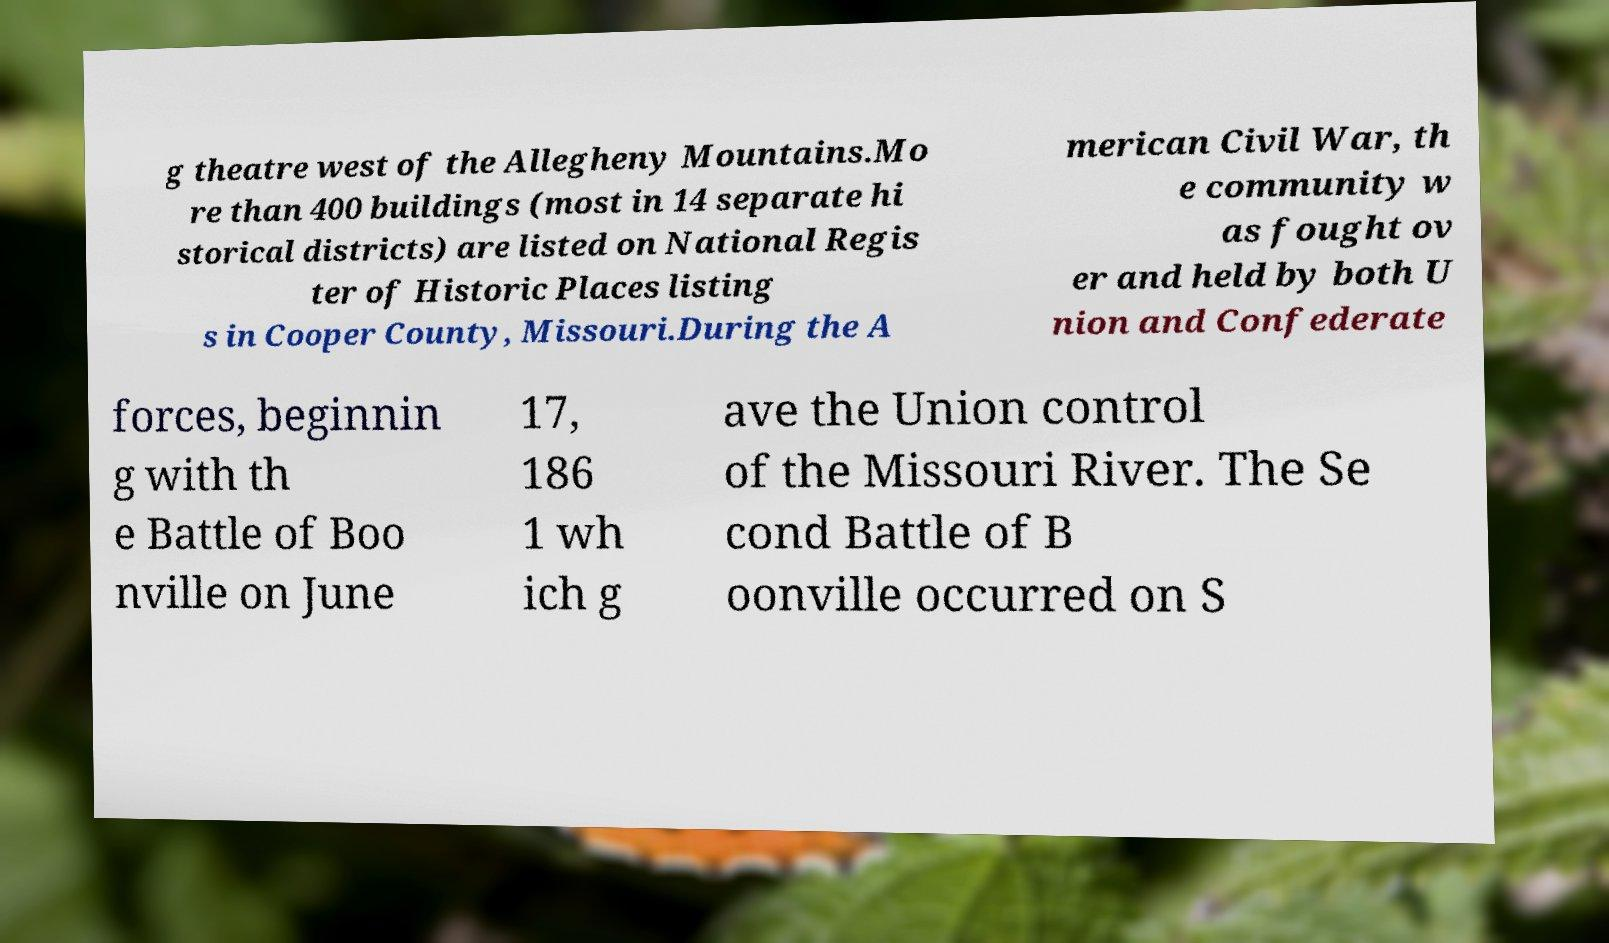Can you accurately transcribe the text from the provided image for me? g theatre west of the Allegheny Mountains.Mo re than 400 buildings (most in 14 separate hi storical districts) are listed on National Regis ter of Historic Places listing s in Cooper County, Missouri.During the A merican Civil War, th e community w as fought ov er and held by both U nion and Confederate forces, beginnin g with th e Battle of Boo nville on June 17, 186 1 wh ich g ave the Union control of the Missouri River. The Se cond Battle of B oonville occurred on S 